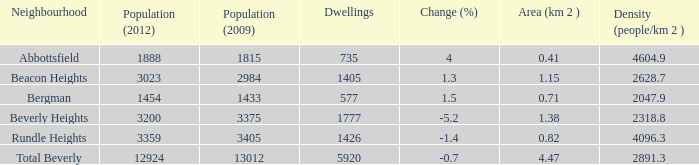What is the density of an area that is 1.38km and has a population more than 12924? 0.0. 